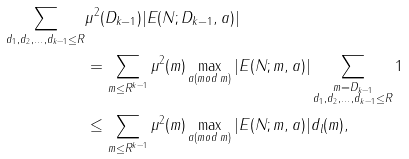<formula> <loc_0><loc_0><loc_500><loc_500>\sum _ { d _ { 1 } , d _ { 2 } , \dots , d _ { k - 1 } \leq R } & \mu ^ { 2 } ( D _ { k - 1 } ) | E ( N ; D _ { k - 1 } , a ) | \\ & = \sum _ { m \leq R ^ { k - 1 } } \mu ^ { 2 } ( m ) \max _ { a ( m o d \, m ) } | E ( N ; m , a ) | \sum _ { \substack { m = D _ { k - 1 } \\ d _ { 1 } , d _ { 2 } , \dots , d _ { k - 1 } \leq R } } 1 \\ & \leq \sum _ { m \leq R ^ { k - 1 } } \mu ^ { 2 } ( m ) \max _ { a ( m o d \, m ) } | E ( N ; m , a ) | d _ { l } ( m ) ,</formula> 